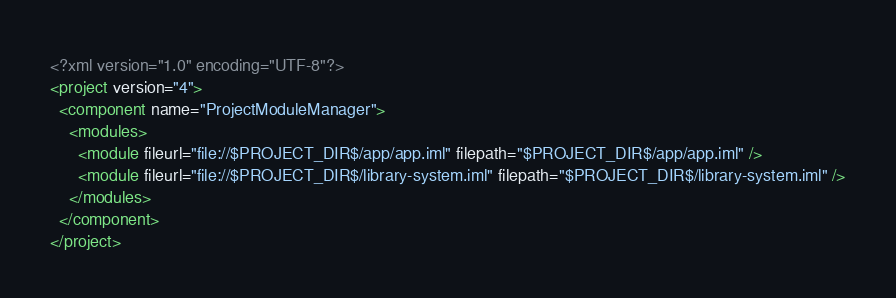Convert code to text. <code><loc_0><loc_0><loc_500><loc_500><_XML_><?xml version="1.0" encoding="UTF-8"?>
<project version="4">
  <component name="ProjectModuleManager">
    <modules>
      <module fileurl="file://$PROJECT_DIR$/app/app.iml" filepath="$PROJECT_DIR$/app/app.iml" />
      <module fileurl="file://$PROJECT_DIR$/library-system.iml" filepath="$PROJECT_DIR$/library-system.iml" />
    </modules>
  </component>
</project></code> 